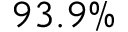<formula> <loc_0><loc_0><loc_500><loc_500>9 3 . 9 \%</formula> 